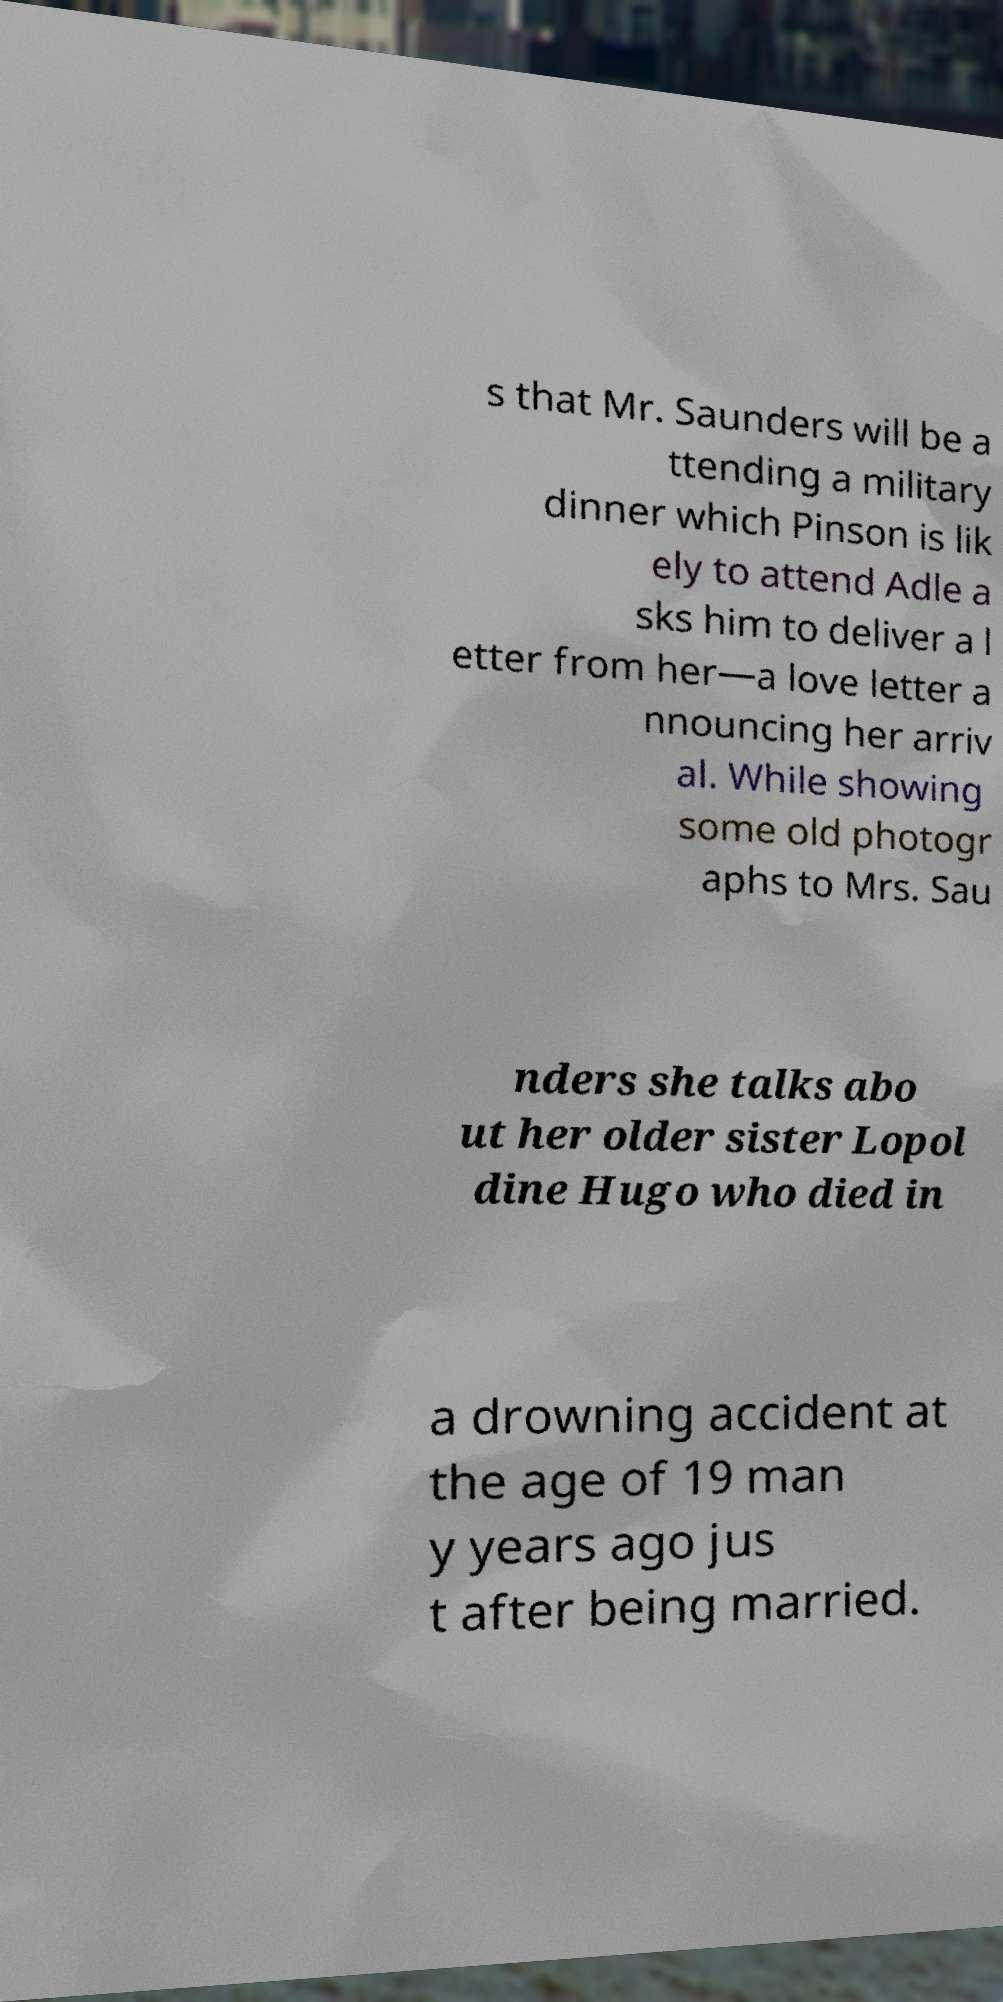Could you extract and type out the text from this image? s that Mr. Saunders will be a ttending a military dinner which Pinson is lik ely to attend Adle a sks him to deliver a l etter from her—a love letter a nnouncing her arriv al. While showing some old photogr aphs to Mrs. Sau nders she talks abo ut her older sister Lopol dine Hugo who died in a drowning accident at the age of 19 man y years ago jus t after being married. 